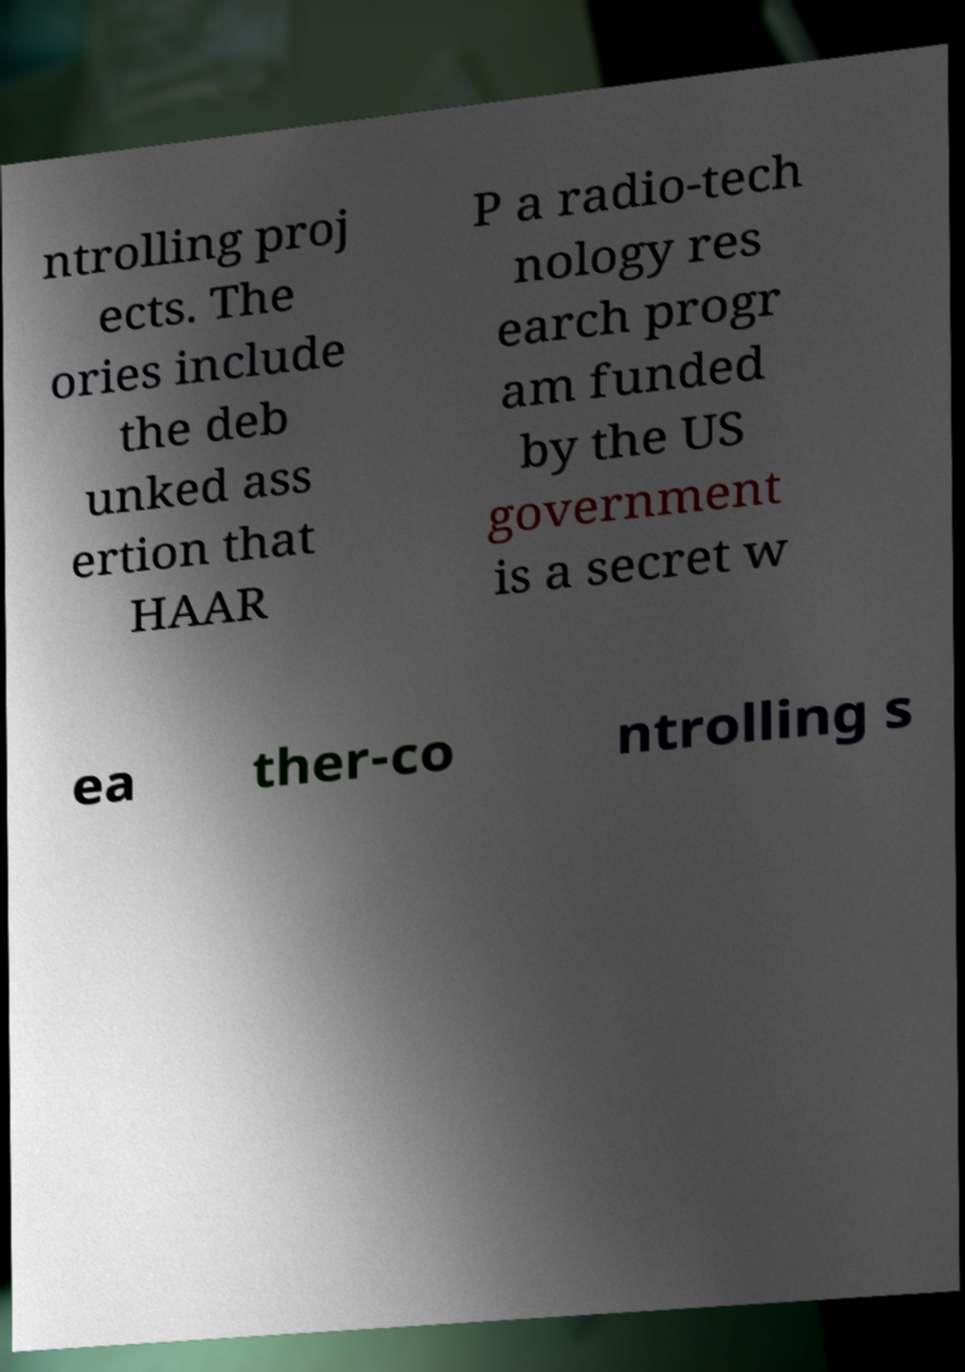For documentation purposes, I need the text within this image transcribed. Could you provide that? ntrolling proj ects. The ories include the deb unked ass ertion that HAAR P a radio-tech nology res earch progr am funded by the US government is a secret w ea ther-co ntrolling s 